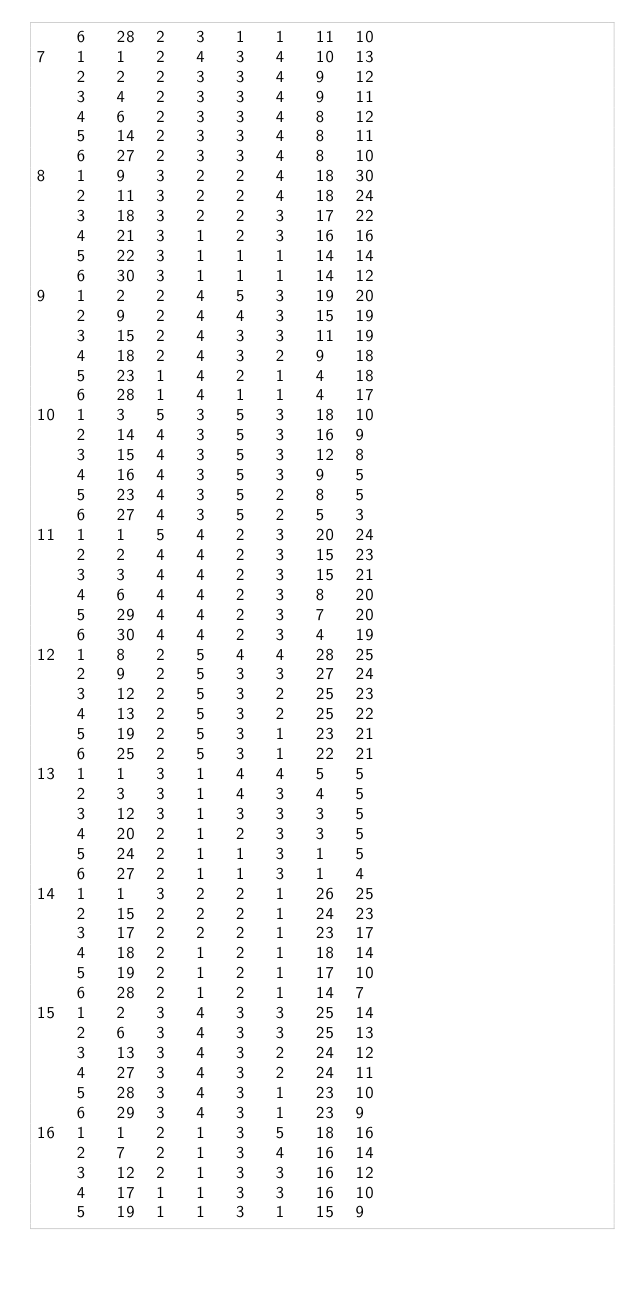Convert code to text. <code><loc_0><loc_0><loc_500><loc_500><_ObjectiveC_>	6	28	2	3	1	1	11	10	
7	1	1	2	4	3	4	10	13	
	2	2	2	3	3	4	9	12	
	3	4	2	3	3	4	9	11	
	4	6	2	3	3	4	8	12	
	5	14	2	3	3	4	8	11	
	6	27	2	3	3	4	8	10	
8	1	9	3	2	2	4	18	30	
	2	11	3	2	2	4	18	24	
	3	18	3	2	2	3	17	22	
	4	21	3	1	2	3	16	16	
	5	22	3	1	1	1	14	14	
	6	30	3	1	1	1	14	12	
9	1	2	2	4	5	3	19	20	
	2	9	2	4	4	3	15	19	
	3	15	2	4	3	3	11	19	
	4	18	2	4	3	2	9	18	
	5	23	1	4	2	1	4	18	
	6	28	1	4	1	1	4	17	
10	1	3	5	3	5	3	18	10	
	2	14	4	3	5	3	16	9	
	3	15	4	3	5	3	12	8	
	4	16	4	3	5	3	9	5	
	5	23	4	3	5	2	8	5	
	6	27	4	3	5	2	5	3	
11	1	1	5	4	2	3	20	24	
	2	2	4	4	2	3	15	23	
	3	3	4	4	2	3	15	21	
	4	6	4	4	2	3	8	20	
	5	29	4	4	2	3	7	20	
	6	30	4	4	2	3	4	19	
12	1	8	2	5	4	4	28	25	
	2	9	2	5	3	3	27	24	
	3	12	2	5	3	2	25	23	
	4	13	2	5	3	2	25	22	
	5	19	2	5	3	1	23	21	
	6	25	2	5	3	1	22	21	
13	1	1	3	1	4	4	5	5	
	2	3	3	1	4	3	4	5	
	3	12	3	1	3	3	3	5	
	4	20	2	1	2	3	3	5	
	5	24	2	1	1	3	1	5	
	6	27	2	1	1	3	1	4	
14	1	1	3	2	2	1	26	25	
	2	15	2	2	2	1	24	23	
	3	17	2	2	2	1	23	17	
	4	18	2	1	2	1	18	14	
	5	19	2	1	2	1	17	10	
	6	28	2	1	2	1	14	7	
15	1	2	3	4	3	3	25	14	
	2	6	3	4	3	3	25	13	
	3	13	3	4	3	2	24	12	
	4	27	3	4	3	2	24	11	
	5	28	3	4	3	1	23	10	
	6	29	3	4	3	1	23	9	
16	1	1	2	1	3	5	18	16	
	2	7	2	1	3	4	16	14	
	3	12	2	1	3	3	16	12	
	4	17	1	1	3	3	16	10	
	5	19	1	1	3	1	15	9	</code> 